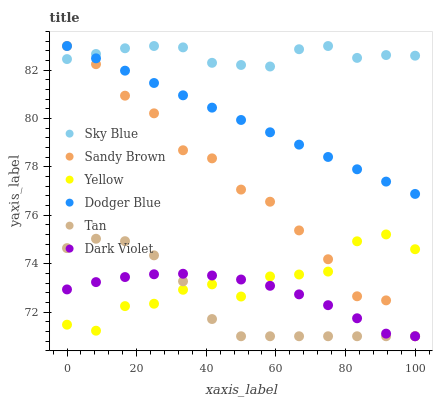Does Tan have the minimum area under the curve?
Answer yes or no. Yes. Does Sky Blue have the maximum area under the curve?
Answer yes or no. Yes. Does Dodger Blue have the minimum area under the curve?
Answer yes or no. No. Does Dodger Blue have the maximum area under the curve?
Answer yes or no. No. Is Dodger Blue the smoothest?
Answer yes or no. Yes. Is Yellow the roughest?
Answer yes or no. Yes. Is Yellow the smoothest?
Answer yes or no. No. Is Dodger Blue the roughest?
Answer yes or no. No. Does Dark Violet have the lowest value?
Answer yes or no. Yes. Does Dodger Blue have the lowest value?
Answer yes or no. No. Does Sandy Brown have the highest value?
Answer yes or no. Yes. Does Yellow have the highest value?
Answer yes or no. No. Is Dark Violet less than Dodger Blue?
Answer yes or no. Yes. Is Sky Blue greater than Tan?
Answer yes or no. Yes. Does Dark Violet intersect Yellow?
Answer yes or no. Yes. Is Dark Violet less than Yellow?
Answer yes or no. No. Is Dark Violet greater than Yellow?
Answer yes or no. No. Does Dark Violet intersect Dodger Blue?
Answer yes or no. No. 